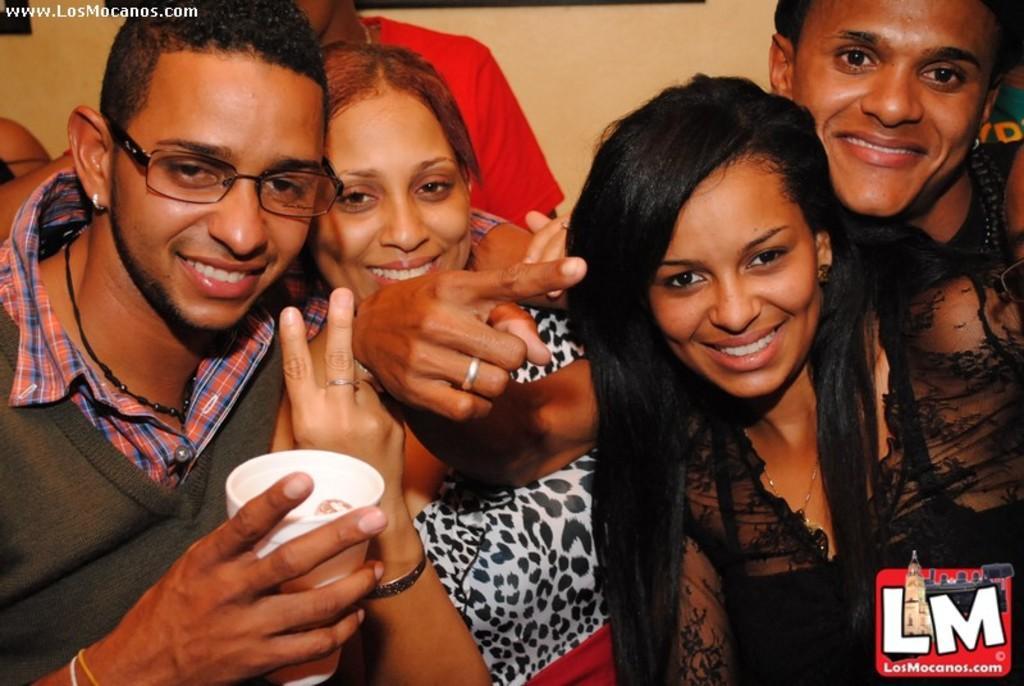Could you give a brief overview of what you see in this image? In this picture I can see there are four people standing and the man on to left is smiling wearing spectacles and holding a disposable cup and there are three other people and they are also smiling. In the backdrop there is a man standing and there is a wall. 